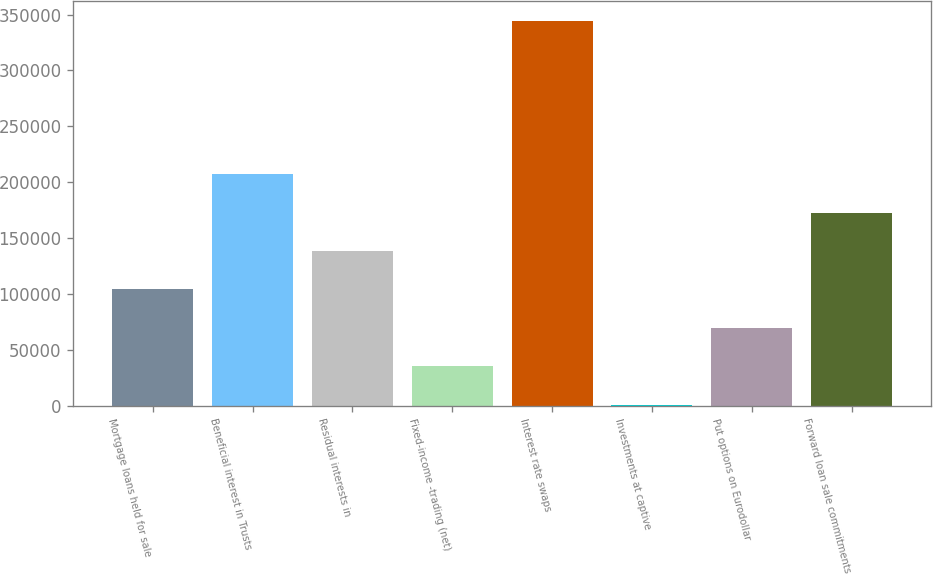<chart> <loc_0><loc_0><loc_500><loc_500><bar_chart><fcel>Mortgage loans held for sale<fcel>Beneficial interest in Trusts<fcel>Residual interests in<fcel>Fixed-income -trading (net)<fcel>Interest rate swaps<fcel>Investments at captive<fcel>Put options on Eurodollar<fcel>Forward loan sale commitments<nl><fcel>103952<fcel>207089<fcel>138331<fcel>35193.2<fcel>344606<fcel>814<fcel>69572.4<fcel>172710<nl></chart> 